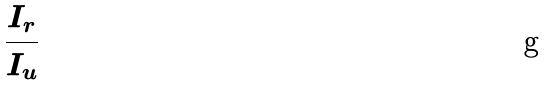Convert formula to latex. <formula><loc_0><loc_0><loc_500><loc_500>\frac { I _ { r } } { I _ { u } }</formula> 